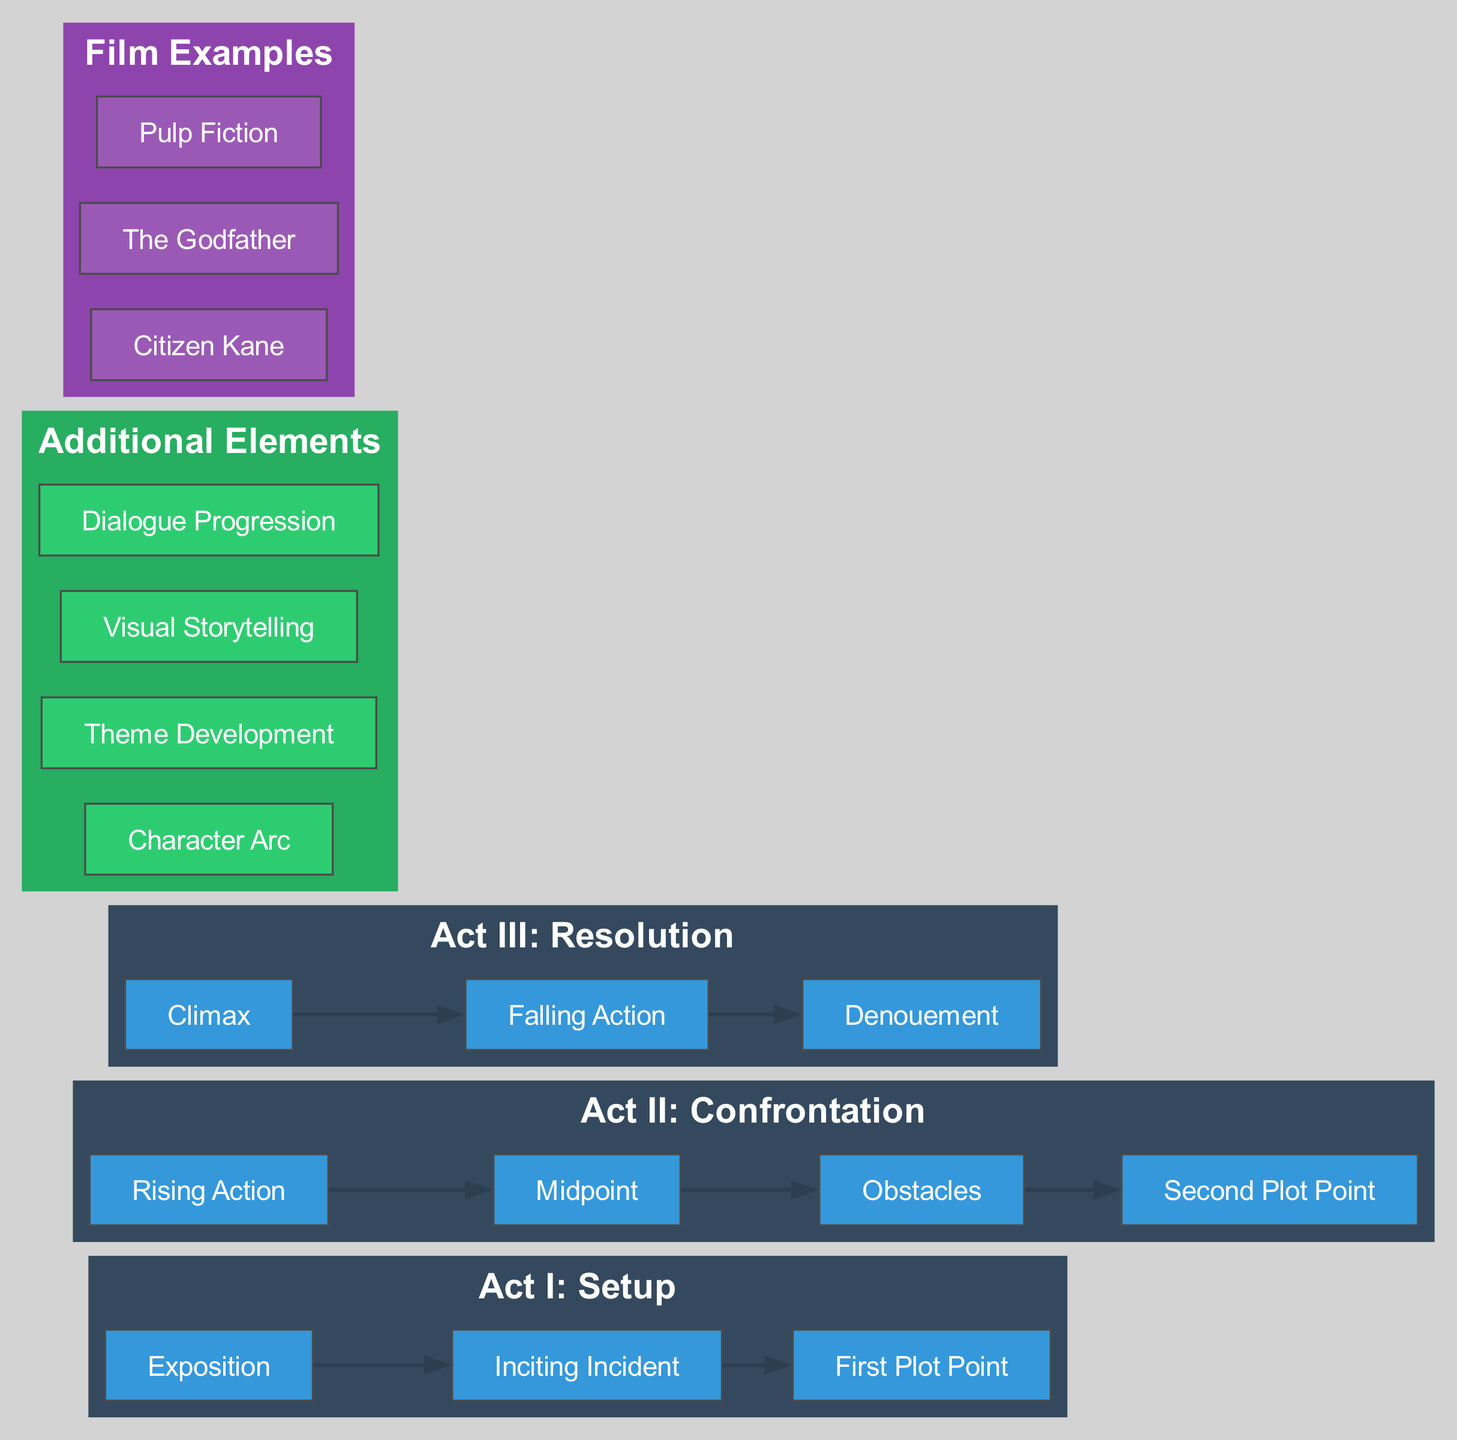What are the three acts of the Three-Act Structure? The diagram clearly outlines the three acts at the top, which are labeled as "Act I: Setup," "Act II: Confrontation," and "Act III: Resolution."
Answer: Act I: Setup, Act II: Confrontation, Act III: Resolution How many elements are in Act II? By counting the listed elements under "Act II: Confrontation," we find four elements: "Rising Action," "Midpoint," "Obstacles," and "Second Plot Point."
Answer: 4 What is the last element of Act I? In the diagram under "Act I: Setup," the elements are shown sequentially. The last element listed is "First Plot Point."
Answer: First Plot Point Which act contains the Climax? The Climax is listed under "Act III: Resolution," indicating that it is the peak moment in the final act of the structure.
Answer: Act III: Resolution What are the two additional elements listed under "Additional Elements"? The diagram lists various elements, but to answer this, we can identify the first two: "Character Arc" and "Theme Development."
Answer: Character Arc, Theme Development Which two acts have a "Plot Point" as their last element? By examining the elements in each act, I find that both "Act I" and "Act II" end with a "Plot Point"—specifically, "First Plot Point" for Act I and "Second Plot Point" for Act II.
Answer: Act I, Act II How many additional elements are there? The visual representation shows four distinct nodes under "Additional Elements," which gives us the total number when counted.
Answer: 4 What film example represents a classic narrative structure? Among the listed film examples, "Citizen Kane" is often regarded as a classic structure, fitting the traditional three-act narrative model.
Answer: Citizen Kane Which act has the most elements? By comparing the number of elements in each of the three acts, Act II: Confrontation has four elements, which is greater than the others that have three and three.
Answer: Act II: Confrontation 